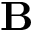<formula> <loc_0><loc_0><loc_500><loc_500>B</formula> 